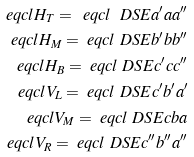<formula> <loc_0><loc_0><loc_500><loc_500>\ e q c l { H _ { T } } = \ e q c l { \ D S E { a ^ { \prime } } { a } { a ^ { \prime \prime } } } \\ \ e q c l { H _ { M } } = \ e q c l { \ D S E { b ^ { \prime } } { b } { b ^ { \prime \prime } } } \\ \ e q c l { H _ { B } } = \ e q c l { \ D S E { c ^ { \prime } } { c } { c ^ { \prime \prime } } } \\ \ e q c l { V _ { L } } = \ e q c l { \ D S E { c ^ { \prime } } { b ^ { \prime } } { a ^ { \prime } } } \\ \ e q c l { V _ { M } } = \ e q c l { \ D S E { c } { b } { a } } \\ \ e q c l { V _ { R } } = \ e q c l { \ D S E { c ^ { \prime \prime } } { b ^ { \prime \prime } } { a ^ { \prime \prime } } }</formula> 